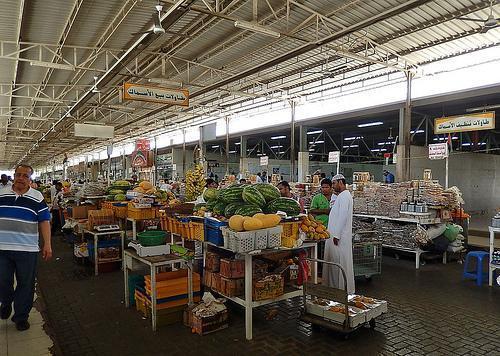How many people are on the left?
Give a very brief answer. 1. 